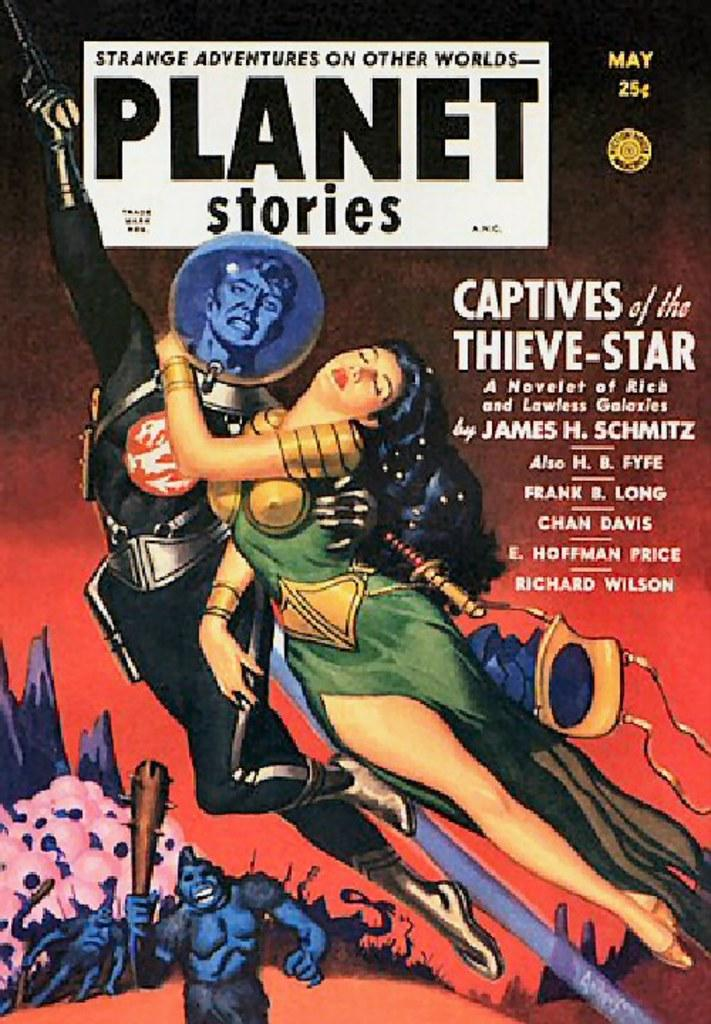<image>
Summarize the visual content of the image. An illustrated book cover with the title "Captives of the Theive Star." 